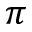<formula> <loc_0><loc_0><loc_500><loc_500>\pi</formula> 